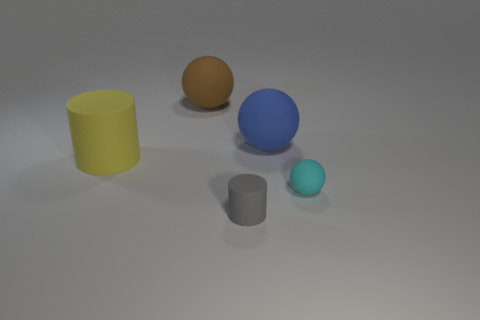Subtract 1 spheres. How many spheres are left? 2 Add 2 large brown metallic balls. How many objects exist? 7 Subtract all balls. How many objects are left? 2 Subtract all gray matte cylinders. Subtract all big yellow cylinders. How many objects are left? 3 Add 5 big matte objects. How many big matte objects are left? 8 Add 5 big yellow matte objects. How many big yellow matte objects exist? 6 Subtract 1 yellow cylinders. How many objects are left? 4 